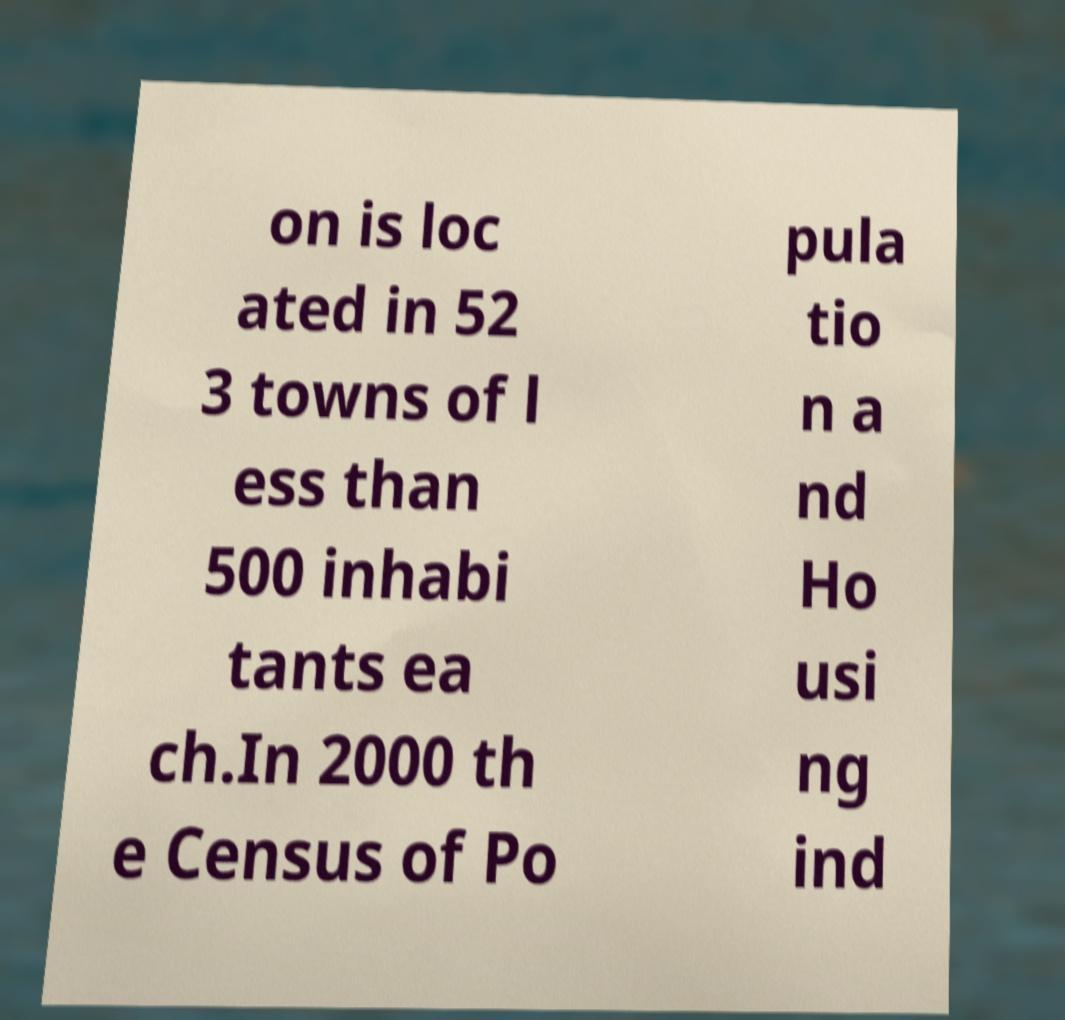What messages or text are displayed in this image? I need them in a readable, typed format. on is loc ated in 52 3 towns of l ess than 500 inhabi tants ea ch.In 2000 th e Census of Po pula tio n a nd Ho usi ng ind 